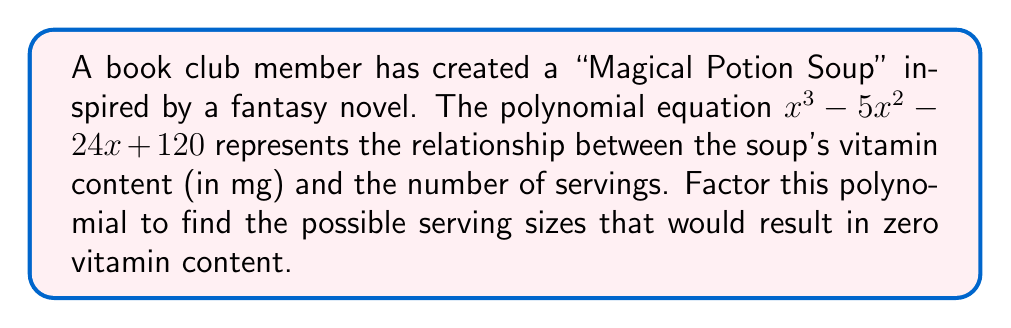Give your solution to this math problem. To factor the polynomial $x^3 - 5x^2 - 24x + 120$, we'll follow these steps:

1) First, let's check if there are any rational roots using the rational root theorem. The possible rational roots are the factors of the constant term (120): ±1, ±2, ±3, ±4, ±5, ±6, ±8, ±10, ±12, ±15, ±20, ±24, ±30, ±40, ±60, ±120.

2) Testing these values, we find that 8 is a root. So $(x - 8)$ is a factor.

3) Divide the polynomial by $(x - 8)$:

   $\frac{x^3 - 5x^2 - 24x + 120}{x - 8} = x^2 + 3x - 15$

4) Now we need to factor the quadratic $x^2 + 3x - 15$. We can do this by finding two numbers that multiply to give -15 and add to give 3. These numbers are 8 and -5.

5) So, $x^2 + 3x - 15 = (x + 8)(x - 5)$

6) Combining all factors, we get:

   $x^3 - 5x^2 - 24x + 120 = (x - 8)(x + 8)(x - 5)$

Therefore, the possible serving sizes that would result in zero vitamin content are 8, -8, and 5.
Answer: $(x - 8)(x + 8)(x - 5)$ 